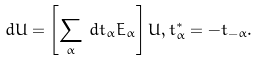Convert formula to latex. <formula><loc_0><loc_0><loc_500><loc_500>d U = \left [ \sum _ { \alpha } \, d t _ { \alpha } E _ { \alpha } \right ] U , t _ { \alpha } ^ { * } = - t _ { - \alpha } .</formula> 